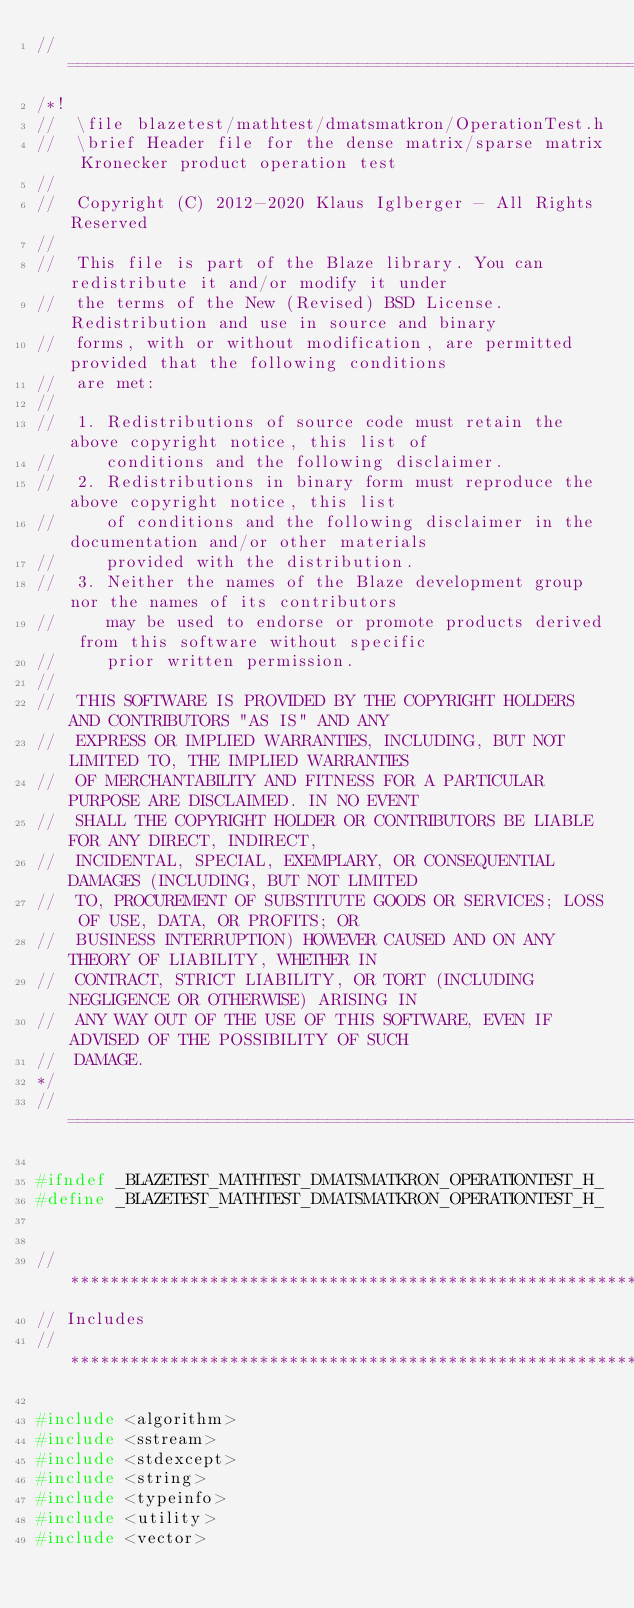Convert code to text. <code><loc_0><loc_0><loc_500><loc_500><_C_>//=================================================================================================
/*!
//  \file blazetest/mathtest/dmatsmatkron/OperationTest.h
//  \brief Header file for the dense matrix/sparse matrix Kronecker product operation test
//
//  Copyright (C) 2012-2020 Klaus Iglberger - All Rights Reserved
//
//  This file is part of the Blaze library. You can redistribute it and/or modify it under
//  the terms of the New (Revised) BSD License. Redistribution and use in source and binary
//  forms, with or without modification, are permitted provided that the following conditions
//  are met:
//
//  1. Redistributions of source code must retain the above copyright notice, this list of
//     conditions and the following disclaimer.
//  2. Redistributions in binary form must reproduce the above copyright notice, this list
//     of conditions and the following disclaimer in the documentation and/or other materials
//     provided with the distribution.
//  3. Neither the names of the Blaze development group nor the names of its contributors
//     may be used to endorse or promote products derived from this software without specific
//     prior written permission.
//
//  THIS SOFTWARE IS PROVIDED BY THE COPYRIGHT HOLDERS AND CONTRIBUTORS "AS IS" AND ANY
//  EXPRESS OR IMPLIED WARRANTIES, INCLUDING, BUT NOT LIMITED TO, THE IMPLIED WARRANTIES
//  OF MERCHANTABILITY AND FITNESS FOR A PARTICULAR PURPOSE ARE DISCLAIMED. IN NO EVENT
//  SHALL THE COPYRIGHT HOLDER OR CONTRIBUTORS BE LIABLE FOR ANY DIRECT, INDIRECT,
//  INCIDENTAL, SPECIAL, EXEMPLARY, OR CONSEQUENTIAL DAMAGES (INCLUDING, BUT NOT LIMITED
//  TO, PROCUREMENT OF SUBSTITUTE GOODS OR SERVICES; LOSS OF USE, DATA, OR PROFITS; OR
//  BUSINESS INTERRUPTION) HOWEVER CAUSED AND ON ANY THEORY OF LIABILITY, WHETHER IN
//  CONTRACT, STRICT LIABILITY, OR TORT (INCLUDING NEGLIGENCE OR OTHERWISE) ARISING IN
//  ANY WAY OUT OF THE USE OF THIS SOFTWARE, EVEN IF ADVISED OF THE POSSIBILITY OF SUCH
//  DAMAGE.
*/
//=================================================================================================

#ifndef _BLAZETEST_MATHTEST_DMATSMATKRON_OPERATIONTEST_H_
#define _BLAZETEST_MATHTEST_DMATSMATKRON_OPERATIONTEST_H_


//*************************************************************************************************
// Includes
//*************************************************************************************************

#include <algorithm>
#include <sstream>
#include <stdexcept>
#include <string>
#include <typeinfo>
#include <utility>
#include <vector></code> 